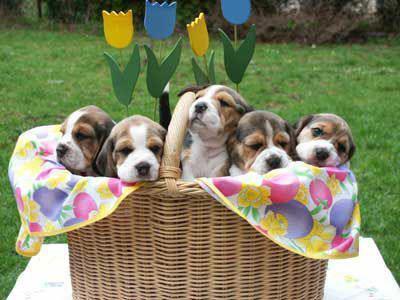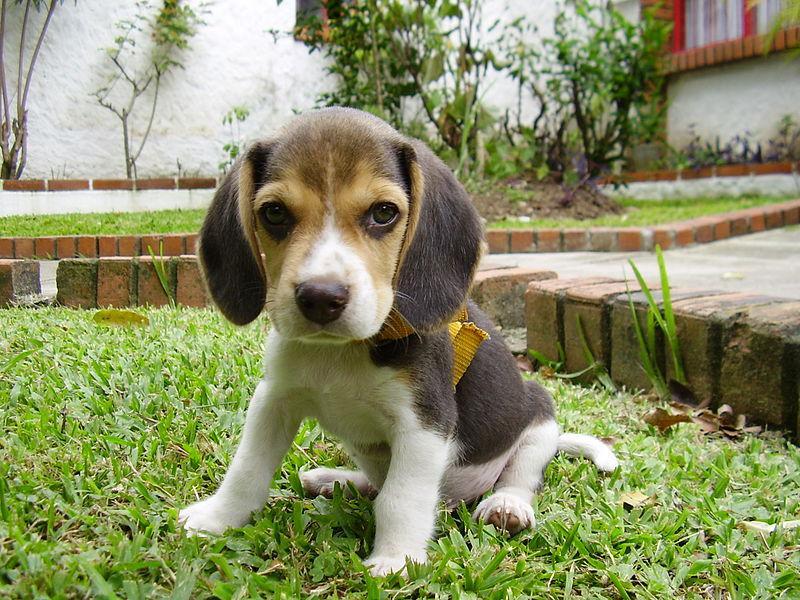The first image is the image on the left, the second image is the image on the right. Considering the images on both sides, is "There are two dogs in the right image." valid? Answer yes or no. No. The first image is the image on the left, the second image is the image on the right. Assess this claim about the two images: "Flowers of some type are behind a dog in at least one image, and at least one image includes a beagle puppy.". Correct or not? Answer yes or no. Yes. 